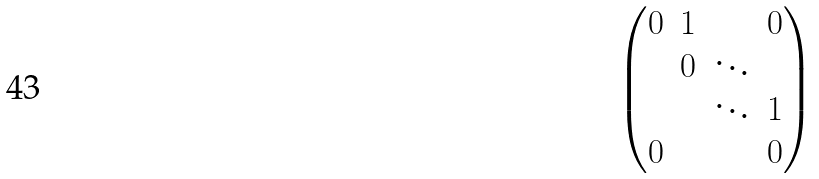<formula> <loc_0><loc_0><loc_500><loc_500>\begin{pmatrix} 0 & 1 & & 0 \\ & 0 & \ddots & \\ & & \ddots & 1 \\ 0 & & & 0 \end{pmatrix}</formula> 